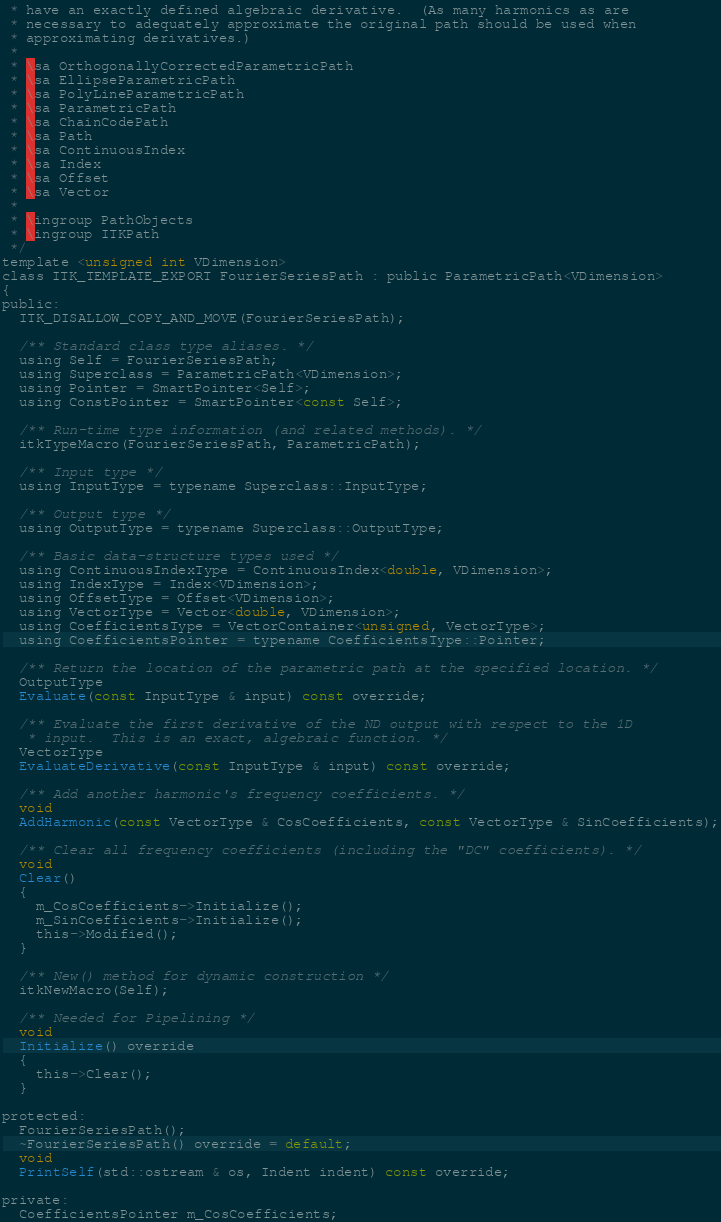<code> <loc_0><loc_0><loc_500><loc_500><_C_> * have an exactly defined algebraic derivative.  (As many harmonics as are
 * necessary to adequately approximate the original path should be used when
 * approximating derivatives.)
 *
 * \sa OrthogonallyCorrectedParametricPath
 * \sa EllipseParametricPath
 * \sa PolyLineParametricPath
 * \sa ParametricPath
 * \sa ChainCodePath
 * \sa Path
 * \sa ContinuousIndex
 * \sa Index
 * \sa Offset
 * \sa Vector
 *
 * \ingroup PathObjects
 * \ingroup ITKPath
 */
template <unsigned int VDimension>
class ITK_TEMPLATE_EXPORT FourierSeriesPath : public ParametricPath<VDimension>
{
public:
  ITK_DISALLOW_COPY_AND_MOVE(FourierSeriesPath);

  /** Standard class type aliases. */
  using Self = FourierSeriesPath;
  using Superclass = ParametricPath<VDimension>;
  using Pointer = SmartPointer<Self>;
  using ConstPointer = SmartPointer<const Self>;

  /** Run-time type information (and related methods). */
  itkTypeMacro(FourierSeriesPath, ParametricPath);

  /** Input type */
  using InputType = typename Superclass::InputType;

  /** Output type */
  using OutputType = typename Superclass::OutputType;

  /** Basic data-structure types used */
  using ContinuousIndexType = ContinuousIndex<double, VDimension>;
  using IndexType = Index<VDimension>;
  using OffsetType = Offset<VDimension>;
  using VectorType = Vector<double, VDimension>;
  using CoefficientsType = VectorContainer<unsigned, VectorType>;
  using CoefficientsPointer = typename CoefficientsType::Pointer;

  /** Return the location of the parametric path at the specified location. */
  OutputType
  Evaluate(const InputType & input) const override;

  /** Evaluate the first derivative of the ND output with respect to the 1D
   * input.  This is an exact, algebraic function. */
  VectorType
  EvaluateDerivative(const InputType & input) const override;

  /** Add another harmonic's frequency coefficients. */
  void
  AddHarmonic(const VectorType & CosCoefficients, const VectorType & SinCoefficients);

  /** Clear all frequency coefficients (including the "DC" coefficients). */
  void
  Clear()
  {
    m_CosCoefficients->Initialize();
    m_SinCoefficients->Initialize();
    this->Modified();
  }

  /** New() method for dynamic construction */
  itkNewMacro(Self);

  /** Needed for Pipelining */
  void
  Initialize() override
  {
    this->Clear();
  }

protected:
  FourierSeriesPath();
  ~FourierSeriesPath() override = default;
  void
  PrintSelf(std::ostream & os, Indent indent) const override;

private:
  CoefficientsPointer m_CosCoefficients;</code> 